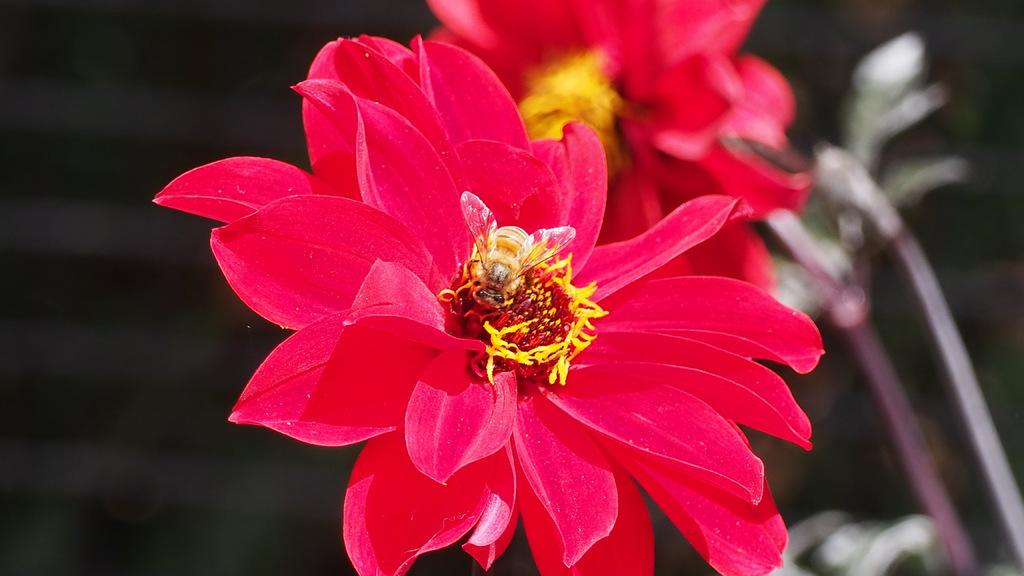What type of living organisms can be seen in the image? There are flowers in the image. What can be seen in the background of the image? There are plants in the background of the image. What type of flesh can be seen in the image? There is no flesh present in the image; it features flowers and plants. What texture can be observed in the image? The texture of the flowers and plants in the image cannot be determined from the image alone, as texture is a tactile quality. 